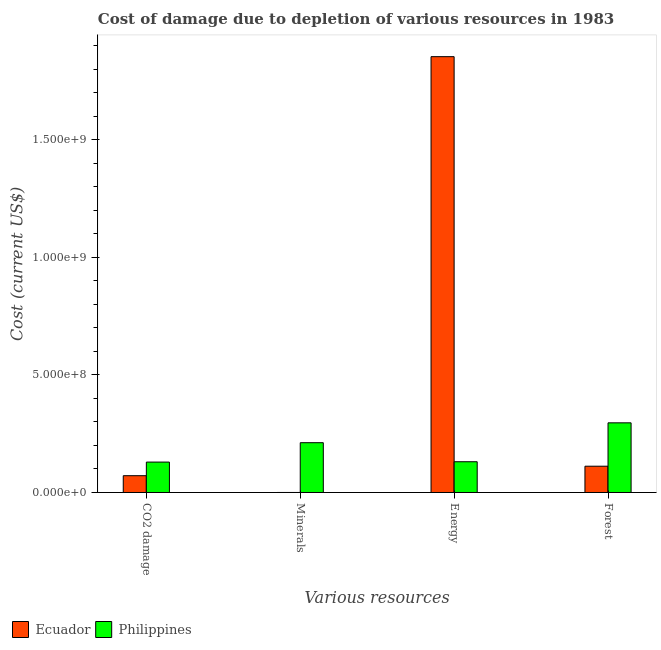Are the number of bars per tick equal to the number of legend labels?
Provide a short and direct response. Yes. Are the number of bars on each tick of the X-axis equal?
Provide a succinct answer. Yes. What is the label of the 1st group of bars from the left?
Give a very brief answer. CO2 damage. What is the cost of damage due to depletion of energy in Philippines?
Make the answer very short. 1.31e+08. Across all countries, what is the maximum cost of damage due to depletion of forests?
Your answer should be very brief. 2.96e+08. Across all countries, what is the minimum cost of damage due to depletion of forests?
Offer a very short reply. 1.12e+08. In which country was the cost of damage due to depletion of minerals maximum?
Keep it short and to the point. Philippines. In which country was the cost of damage due to depletion of coal minimum?
Keep it short and to the point. Ecuador. What is the total cost of damage due to depletion of forests in the graph?
Provide a short and direct response. 4.08e+08. What is the difference between the cost of damage due to depletion of coal in Ecuador and that in Philippines?
Your answer should be very brief. -5.79e+07. What is the difference between the cost of damage due to depletion of minerals in Philippines and the cost of damage due to depletion of forests in Ecuador?
Keep it short and to the point. 1.00e+08. What is the average cost of damage due to depletion of energy per country?
Your response must be concise. 9.93e+08. What is the difference between the cost of damage due to depletion of energy and cost of damage due to depletion of forests in Philippines?
Your answer should be very brief. -1.66e+08. In how many countries, is the cost of damage due to depletion of coal greater than 400000000 US$?
Offer a terse response. 0. What is the ratio of the cost of damage due to depletion of energy in Ecuador to that in Philippines?
Make the answer very short. 14.17. Is the cost of damage due to depletion of forests in Ecuador less than that in Philippines?
Your answer should be very brief. Yes. What is the difference between the highest and the second highest cost of damage due to depletion of energy?
Ensure brevity in your answer.  1.72e+09. What is the difference between the highest and the lowest cost of damage due to depletion of forests?
Keep it short and to the point. 1.85e+08. What does the 2nd bar from the right in Energy represents?
Keep it short and to the point. Ecuador. Is it the case that in every country, the sum of the cost of damage due to depletion of coal and cost of damage due to depletion of minerals is greater than the cost of damage due to depletion of energy?
Ensure brevity in your answer.  No. Are all the bars in the graph horizontal?
Your answer should be very brief. No. What is the difference between two consecutive major ticks on the Y-axis?
Your answer should be compact. 5.00e+08. Where does the legend appear in the graph?
Provide a succinct answer. Bottom left. How many legend labels are there?
Ensure brevity in your answer.  2. How are the legend labels stacked?
Offer a terse response. Horizontal. What is the title of the graph?
Give a very brief answer. Cost of damage due to depletion of various resources in 1983 . Does "Channel Islands" appear as one of the legend labels in the graph?
Give a very brief answer. No. What is the label or title of the X-axis?
Offer a very short reply. Various resources. What is the label or title of the Y-axis?
Provide a short and direct response. Cost (current US$). What is the Cost (current US$) of Ecuador in CO2 damage?
Make the answer very short. 7.14e+07. What is the Cost (current US$) in Philippines in CO2 damage?
Your answer should be very brief. 1.29e+08. What is the Cost (current US$) in Ecuador in Minerals?
Ensure brevity in your answer.  4.22e+04. What is the Cost (current US$) of Philippines in Minerals?
Offer a very short reply. 2.12e+08. What is the Cost (current US$) of Ecuador in Energy?
Give a very brief answer. 1.85e+09. What is the Cost (current US$) in Philippines in Energy?
Give a very brief answer. 1.31e+08. What is the Cost (current US$) in Ecuador in Forest?
Offer a very short reply. 1.12e+08. What is the Cost (current US$) of Philippines in Forest?
Offer a very short reply. 2.96e+08. Across all Various resources, what is the maximum Cost (current US$) of Ecuador?
Provide a succinct answer. 1.85e+09. Across all Various resources, what is the maximum Cost (current US$) of Philippines?
Give a very brief answer. 2.96e+08. Across all Various resources, what is the minimum Cost (current US$) of Ecuador?
Ensure brevity in your answer.  4.22e+04. Across all Various resources, what is the minimum Cost (current US$) in Philippines?
Offer a terse response. 1.29e+08. What is the total Cost (current US$) of Ecuador in the graph?
Provide a succinct answer. 2.04e+09. What is the total Cost (current US$) of Philippines in the graph?
Provide a short and direct response. 7.68e+08. What is the difference between the Cost (current US$) of Ecuador in CO2 damage and that in Minerals?
Your response must be concise. 7.14e+07. What is the difference between the Cost (current US$) of Philippines in CO2 damage and that in Minerals?
Offer a terse response. -8.25e+07. What is the difference between the Cost (current US$) in Ecuador in CO2 damage and that in Energy?
Offer a very short reply. -1.78e+09. What is the difference between the Cost (current US$) of Philippines in CO2 damage and that in Energy?
Give a very brief answer. -1.48e+06. What is the difference between the Cost (current US$) of Ecuador in CO2 damage and that in Forest?
Ensure brevity in your answer.  -4.04e+07. What is the difference between the Cost (current US$) of Philippines in CO2 damage and that in Forest?
Offer a terse response. -1.67e+08. What is the difference between the Cost (current US$) in Ecuador in Minerals and that in Energy?
Your answer should be compact. -1.85e+09. What is the difference between the Cost (current US$) in Philippines in Minerals and that in Energy?
Keep it short and to the point. 8.10e+07. What is the difference between the Cost (current US$) of Ecuador in Minerals and that in Forest?
Offer a very short reply. -1.12e+08. What is the difference between the Cost (current US$) in Philippines in Minerals and that in Forest?
Give a very brief answer. -8.45e+07. What is the difference between the Cost (current US$) in Ecuador in Energy and that in Forest?
Give a very brief answer. 1.74e+09. What is the difference between the Cost (current US$) in Philippines in Energy and that in Forest?
Make the answer very short. -1.66e+08. What is the difference between the Cost (current US$) in Ecuador in CO2 damage and the Cost (current US$) in Philippines in Minerals?
Your answer should be compact. -1.40e+08. What is the difference between the Cost (current US$) in Ecuador in CO2 damage and the Cost (current US$) in Philippines in Energy?
Ensure brevity in your answer.  -5.94e+07. What is the difference between the Cost (current US$) of Ecuador in CO2 damage and the Cost (current US$) of Philippines in Forest?
Your response must be concise. -2.25e+08. What is the difference between the Cost (current US$) in Ecuador in Minerals and the Cost (current US$) in Philippines in Energy?
Your response must be concise. -1.31e+08. What is the difference between the Cost (current US$) of Ecuador in Minerals and the Cost (current US$) of Philippines in Forest?
Provide a succinct answer. -2.96e+08. What is the difference between the Cost (current US$) in Ecuador in Energy and the Cost (current US$) in Philippines in Forest?
Your answer should be very brief. 1.56e+09. What is the average Cost (current US$) in Ecuador per Various resources?
Provide a short and direct response. 5.09e+08. What is the average Cost (current US$) of Philippines per Various resources?
Provide a short and direct response. 1.92e+08. What is the difference between the Cost (current US$) in Ecuador and Cost (current US$) in Philippines in CO2 damage?
Your answer should be compact. -5.79e+07. What is the difference between the Cost (current US$) of Ecuador and Cost (current US$) of Philippines in Minerals?
Provide a short and direct response. -2.12e+08. What is the difference between the Cost (current US$) in Ecuador and Cost (current US$) in Philippines in Energy?
Your answer should be very brief. 1.72e+09. What is the difference between the Cost (current US$) of Ecuador and Cost (current US$) of Philippines in Forest?
Provide a succinct answer. -1.85e+08. What is the ratio of the Cost (current US$) in Ecuador in CO2 damage to that in Minerals?
Provide a succinct answer. 1693.11. What is the ratio of the Cost (current US$) of Philippines in CO2 damage to that in Minerals?
Offer a very short reply. 0.61. What is the ratio of the Cost (current US$) in Ecuador in CO2 damage to that in Energy?
Your answer should be compact. 0.04. What is the ratio of the Cost (current US$) of Philippines in CO2 damage to that in Energy?
Keep it short and to the point. 0.99. What is the ratio of the Cost (current US$) of Ecuador in CO2 damage to that in Forest?
Provide a succinct answer. 0.64. What is the ratio of the Cost (current US$) of Philippines in CO2 damage to that in Forest?
Provide a short and direct response. 0.44. What is the ratio of the Cost (current US$) of Philippines in Minerals to that in Energy?
Provide a succinct answer. 1.62. What is the ratio of the Cost (current US$) in Philippines in Minerals to that in Forest?
Your response must be concise. 0.71. What is the ratio of the Cost (current US$) in Ecuador in Energy to that in Forest?
Offer a very short reply. 16.59. What is the ratio of the Cost (current US$) in Philippines in Energy to that in Forest?
Ensure brevity in your answer.  0.44. What is the difference between the highest and the second highest Cost (current US$) in Ecuador?
Provide a succinct answer. 1.74e+09. What is the difference between the highest and the second highest Cost (current US$) in Philippines?
Keep it short and to the point. 8.45e+07. What is the difference between the highest and the lowest Cost (current US$) in Ecuador?
Offer a very short reply. 1.85e+09. What is the difference between the highest and the lowest Cost (current US$) in Philippines?
Provide a succinct answer. 1.67e+08. 